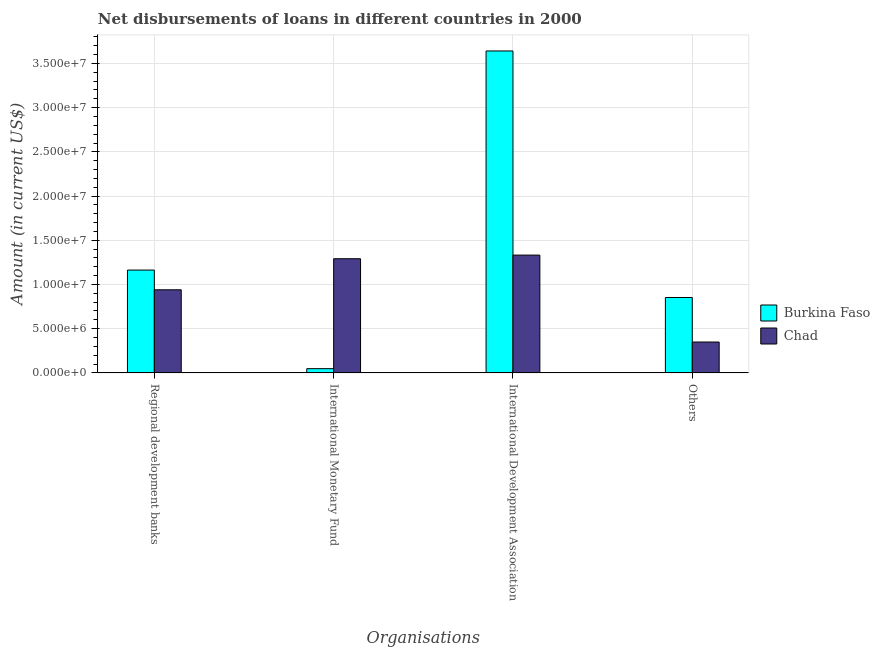How many different coloured bars are there?
Your answer should be compact. 2. How many bars are there on the 2nd tick from the left?
Offer a very short reply. 2. How many bars are there on the 4th tick from the right?
Keep it short and to the point. 2. What is the label of the 1st group of bars from the left?
Offer a terse response. Regional development banks. What is the amount of loan disimbursed by international development association in Burkina Faso?
Provide a succinct answer. 3.64e+07. Across all countries, what is the maximum amount of loan disimbursed by international development association?
Keep it short and to the point. 3.64e+07. Across all countries, what is the minimum amount of loan disimbursed by international development association?
Give a very brief answer. 1.33e+07. In which country was the amount of loan disimbursed by international development association maximum?
Your answer should be very brief. Burkina Faso. In which country was the amount of loan disimbursed by regional development banks minimum?
Give a very brief answer. Chad. What is the total amount of loan disimbursed by international development association in the graph?
Offer a terse response. 4.97e+07. What is the difference between the amount of loan disimbursed by other organisations in Chad and that in Burkina Faso?
Give a very brief answer. -5.04e+06. What is the difference between the amount of loan disimbursed by other organisations in Chad and the amount of loan disimbursed by international development association in Burkina Faso?
Make the answer very short. -3.29e+07. What is the average amount of loan disimbursed by international development association per country?
Give a very brief answer. 2.49e+07. What is the difference between the amount of loan disimbursed by international development association and amount of loan disimbursed by other organisations in Chad?
Your answer should be compact. 9.83e+06. What is the ratio of the amount of loan disimbursed by regional development banks in Chad to that in Burkina Faso?
Keep it short and to the point. 0.81. Is the amount of loan disimbursed by international development association in Burkina Faso less than that in Chad?
Your answer should be compact. No. What is the difference between the highest and the second highest amount of loan disimbursed by other organisations?
Offer a very short reply. 5.04e+06. What is the difference between the highest and the lowest amount of loan disimbursed by regional development banks?
Your answer should be compact. 2.23e+06. In how many countries, is the amount of loan disimbursed by international monetary fund greater than the average amount of loan disimbursed by international monetary fund taken over all countries?
Make the answer very short. 1. Is it the case that in every country, the sum of the amount of loan disimbursed by regional development banks and amount of loan disimbursed by international monetary fund is greater than the sum of amount of loan disimbursed by other organisations and amount of loan disimbursed by international development association?
Your answer should be very brief. No. What does the 1st bar from the left in International Monetary Fund represents?
Provide a short and direct response. Burkina Faso. What does the 2nd bar from the right in International Development Association represents?
Give a very brief answer. Burkina Faso. Is it the case that in every country, the sum of the amount of loan disimbursed by regional development banks and amount of loan disimbursed by international monetary fund is greater than the amount of loan disimbursed by international development association?
Your response must be concise. No. How many bars are there?
Provide a short and direct response. 8. Are all the bars in the graph horizontal?
Provide a short and direct response. No. How many countries are there in the graph?
Give a very brief answer. 2. Are the values on the major ticks of Y-axis written in scientific E-notation?
Provide a succinct answer. Yes. Does the graph contain any zero values?
Provide a succinct answer. No. Does the graph contain grids?
Make the answer very short. Yes. What is the title of the graph?
Give a very brief answer. Net disbursements of loans in different countries in 2000. What is the label or title of the X-axis?
Ensure brevity in your answer.  Organisations. What is the label or title of the Y-axis?
Offer a terse response. Amount (in current US$). What is the Amount (in current US$) of Burkina Faso in Regional development banks?
Ensure brevity in your answer.  1.16e+07. What is the Amount (in current US$) in Chad in Regional development banks?
Offer a terse response. 9.40e+06. What is the Amount (in current US$) in Burkina Faso in International Monetary Fund?
Make the answer very short. 4.75e+05. What is the Amount (in current US$) of Chad in International Monetary Fund?
Offer a very short reply. 1.29e+07. What is the Amount (in current US$) of Burkina Faso in International Development Association?
Keep it short and to the point. 3.64e+07. What is the Amount (in current US$) of Chad in International Development Association?
Your response must be concise. 1.33e+07. What is the Amount (in current US$) of Burkina Faso in Others?
Your answer should be compact. 8.52e+06. What is the Amount (in current US$) in Chad in Others?
Make the answer very short. 3.49e+06. Across all Organisations, what is the maximum Amount (in current US$) of Burkina Faso?
Provide a short and direct response. 3.64e+07. Across all Organisations, what is the maximum Amount (in current US$) of Chad?
Your answer should be very brief. 1.33e+07. Across all Organisations, what is the minimum Amount (in current US$) in Burkina Faso?
Provide a short and direct response. 4.75e+05. Across all Organisations, what is the minimum Amount (in current US$) in Chad?
Keep it short and to the point. 3.49e+06. What is the total Amount (in current US$) in Burkina Faso in the graph?
Offer a very short reply. 5.70e+07. What is the total Amount (in current US$) in Chad in the graph?
Your response must be concise. 3.91e+07. What is the difference between the Amount (in current US$) of Burkina Faso in Regional development banks and that in International Monetary Fund?
Ensure brevity in your answer.  1.12e+07. What is the difference between the Amount (in current US$) in Chad in Regional development banks and that in International Monetary Fund?
Your answer should be compact. -3.51e+06. What is the difference between the Amount (in current US$) in Burkina Faso in Regional development banks and that in International Development Association?
Give a very brief answer. -2.48e+07. What is the difference between the Amount (in current US$) of Chad in Regional development banks and that in International Development Association?
Your answer should be very brief. -3.92e+06. What is the difference between the Amount (in current US$) in Burkina Faso in Regional development banks and that in Others?
Your answer should be very brief. 3.10e+06. What is the difference between the Amount (in current US$) in Chad in Regional development banks and that in Others?
Keep it short and to the point. 5.91e+06. What is the difference between the Amount (in current US$) of Burkina Faso in International Monetary Fund and that in International Development Association?
Your answer should be very brief. -3.59e+07. What is the difference between the Amount (in current US$) of Chad in International Monetary Fund and that in International Development Association?
Your answer should be very brief. -4.09e+05. What is the difference between the Amount (in current US$) in Burkina Faso in International Monetary Fund and that in Others?
Your response must be concise. -8.05e+06. What is the difference between the Amount (in current US$) in Chad in International Monetary Fund and that in Others?
Your answer should be compact. 9.42e+06. What is the difference between the Amount (in current US$) in Burkina Faso in International Development Association and that in Others?
Make the answer very short. 2.79e+07. What is the difference between the Amount (in current US$) in Chad in International Development Association and that in Others?
Keep it short and to the point. 9.83e+06. What is the difference between the Amount (in current US$) of Burkina Faso in Regional development banks and the Amount (in current US$) of Chad in International Monetary Fund?
Provide a short and direct response. -1.28e+06. What is the difference between the Amount (in current US$) of Burkina Faso in Regional development banks and the Amount (in current US$) of Chad in International Development Association?
Provide a succinct answer. -1.69e+06. What is the difference between the Amount (in current US$) in Burkina Faso in Regional development banks and the Amount (in current US$) in Chad in Others?
Your answer should be compact. 8.14e+06. What is the difference between the Amount (in current US$) of Burkina Faso in International Monetary Fund and the Amount (in current US$) of Chad in International Development Association?
Give a very brief answer. -1.28e+07. What is the difference between the Amount (in current US$) of Burkina Faso in International Monetary Fund and the Amount (in current US$) of Chad in Others?
Make the answer very short. -3.01e+06. What is the difference between the Amount (in current US$) of Burkina Faso in International Development Association and the Amount (in current US$) of Chad in Others?
Provide a succinct answer. 3.29e+07. What is the average Amount (in current US$) in Burkina Faso per Organisations?
Provide a succinct answer. 1.43e+07. What is the average Amount (in current US$) of Chad per Organisations?
Ensure brevity in your answer.  9.78e+06. What is the difference between the Amount (in current US$) of Burkina Faso and Amount (in current US$) of Chad in Regional development banks?
Your response must be concise. 2.23e+06. What is the difference between the Amount (in current US$) in Burkina Faso and Amount (in current US$) in Chad in International Monetary Fund?
Make the answer very short. -1.24e+07. What is the difference between the Amount (in current US$) of Burkina Faso and Amount (in current US$) of Chad in International Development Association?
Give a very brief answer. 2.31e+07. What is the difference between the Amount (in current US$) in Burkina Faso and Amount (in current US$) in Chad in Others?
Your answer should be compact. 5.04e+06. What is the ratio of the Amount (in current US$) in Burkina Faso in Regional development banks to that in International Monetary Fund?
Your answer should be compact. 24.48. What is the ratio of the Amount (in current US$) of Chad in Regional development banks to that in International Monetary Fund?
Provide a succinct answer. 0.73. What is the ratio of the Amount (in current US$) in Burkina Faso in Regional development banks to that in International Development Association?
Your answer should be very brief. 0.32. What is the ratio of the Amount (in current US$) in Chad in Regional development banks to that in International Development Association?
Your answer should be compact. 0.71. What is the ratio of the Amount (in current US$) of Burkina Faso in Regional development banks to that in Others?
Ensure brevity in your answer.  1.36. What is the ratio of the Amount (in current US$) of Chad in Regional development banks to that in Others?
Offer a very short reply. 2.69. What is the ratio of the Amount (in current US$) of Burkina Faso in International Monetary Fund to that in International Development Association?
Make the answer very short. 0.01. What is the ratio of the Amount (in current US$) of Chad in International Monetary Fund to that in International Development Association?
Ensure brevity in your answer.  0.97. What is the ratio of the Amount (in current US$) in Burkina Faso in International Monetary Fund to that in Others?
Provide a succinct answer. 0.06. What is the ratio of the Amount (in current US$) in Chad in International Monetary Fund to that in Others?
Make the answer very short. 3.7. What is the ratio of the Amount (in current US$) in Burkina Faso in International Development Association to that in Others?
Keep it short and to the point. 4.27. What is the ratio of the Amount (in current US$) of Chad in International Development Association to that in Others?
Make the answer very short. 3.82. What is the difference between the highest and the second highest Amount (in current US$) of Burkina Faso?
Your answer should be compact. 2.48e+07. What is the difference between the highest and the second highest Amount (in current US$) in Chad?
Provide a short and direct response. 4.09e+05. What is the difference between the highest and the lowest Amount (in current US$) in Burkina Faso?
Your response must be concise. 3.59e+07. What is the difference between the highest and the lowest Amount (in current US$) of Chad?
Offer a very short reply. 9.83e+06. 